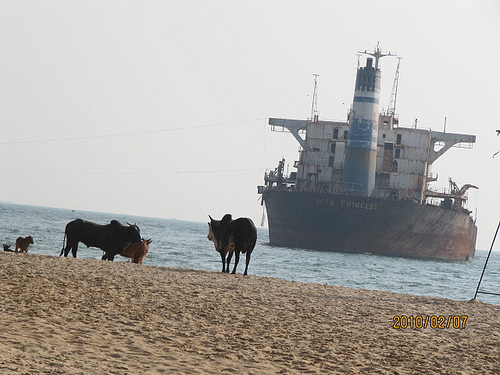<image>Why is the animal on the beach? It is ambiguous why the animal is on the beach. It could be wandering, exercising, or looking for food. Why is the animal on the beach? It is unclear why the animal is on the beach. It can be wandering, exercising, or looking for food. 